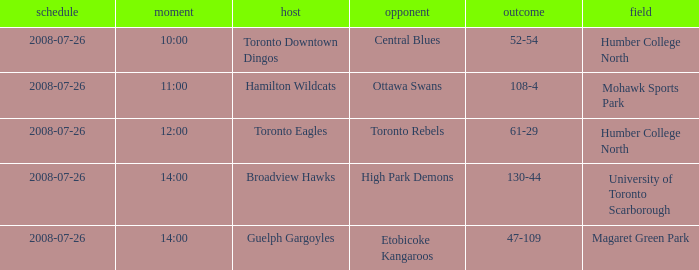The Away High Park Demons was which Ground? University of Toronto Scarborough. 